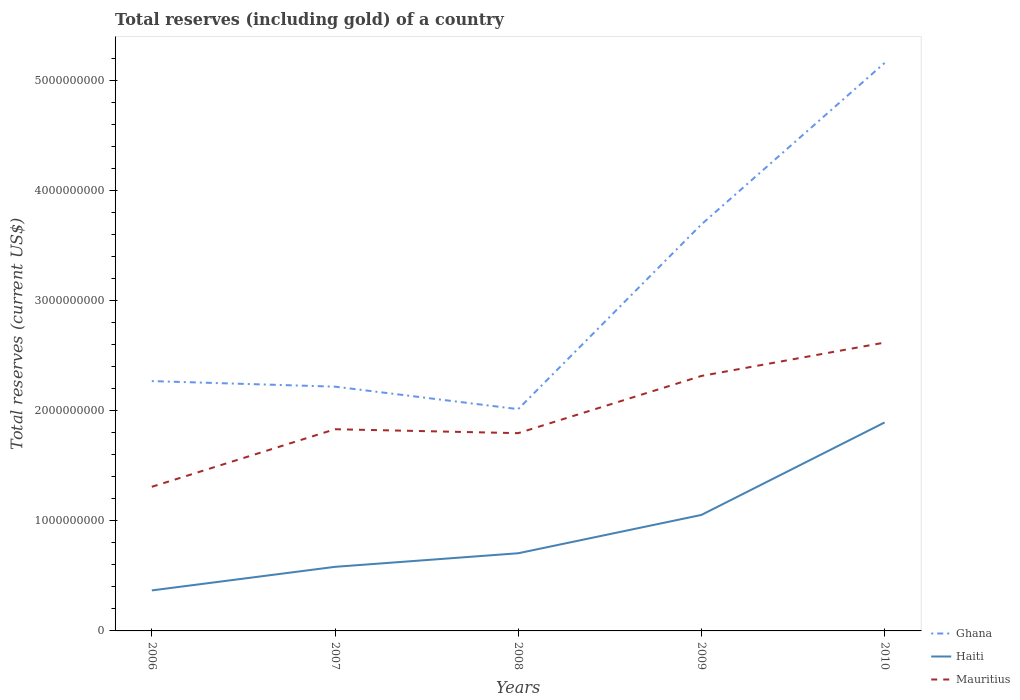Is the number of lines equal to the number of legend labels?
Your answer should be compact. Yes. Across all years, what is the maximum total reserves (including gold) in Haiti?
Your answer should be compact. 3.68e+08. What is the total total reserves (including gold) in Ghana in the graph?
Offer a terse response. 2.55e+08. What is the difference between the highest and the second highest total reserves (including gold) in Mauritius?
Offer a very short reply. 1.31e+09. Is the total reserves (including gold) in Ghana strictly greater than the total reserves (including gold) in Haiti over the years?
Ensure brevity in your answer.  No. What is the difference between two consecutive major ticks on the Y-axis?
Give a very brief answer. 1.00e+09. Does the graph contain any zero values?
Give a very brief answer. No. Does the graph contain grids?
Your answer should be very brief. No. Where does the legend appear in the graph?
Offer a terse response. Bottom right. How many legend labels are there?
Give a very brief answer. 3. What is the title of the graph?
Provide a short and direct response. Total reserves (including gold) of a country. Does "Guinea-Bissau" appear as one of the legend labels in the graph?
Ensure brevity in your answer.  No. What is the label or title of the Y-axis?
Give a very brief answer. Total reserves (current US$). What is the Total reserves (current US$) in Ghana in 2006?
Give a very brief answer. 2.27e+09. What is the Total reserves (current US$) of Haiti in 2006?
Your response must be concise. 3.68e+08. What is the Total reserves (current US$) in Mauritius in 2006?
Give a very brief answer. 1.31e+09. What is the Total reserves (current US$) of Ghana in 2007?
Keep it short and to the point. 2.22e+09. What is the Total reserves (current US$) in Haiti in 2007?
Give a very brief answer. 5.82e+08. What is the Total reserves (current US$) of Mauritius in 2007?
Keep it short and to the point. 1.83e+09. What is the Total reserves (current US$) of Ghana in 2008?
Your answer should be very brief. 2.01e+09. What is the Total reserves (current US$) in Haiti in 2008?
Make the answer very short. 7.05e+08. What is the Total reserves (current US$) in Mauritius in 2008?
Offer a very short reply. 1.80e+09. What is the Total reserves (current US$) of Ghana in 2009?
Provide a succinct answer. 3.69e+09. What is the Total reserves (current US$) in Haiti in 2009?
Keep it short and to the point. 1.05e+09. What is the Total reserves (current US$) of Mauritius in 2009?
Your response must be concise. 2.32e+09. What is the Total reserves (current US$) of Ghana in 2010?
Your answer should be compact. 5.16e+09. What is the Total reserves (current US$) in Haiti in 2010?
Your response must be concise. 1.89e+09. What is the Total reserves (current US$) in Mauritius in 2010?
Make the answer very short. 2.62e+09. Across all years, what is the maximum Total reserves (current US$) in Ghana?
Offer a very short reply. 5.16e+09. Across all years, what is the maximum Total reserves (current US$) in Haiti?
Keep it short and to the point. 1.89e+09. Across all years, what is the maximum Total reserves (current US$) of Mauritius?
Ensure brevity in your answer.  2.62e+09. Across all years, what is the minimum Total reserves (current US$) in Ghana?
Keep it short and to the point. 2.01e+09. Across all years, what is the minimum Total reserves (current US$) in Haiti?
Make the answer very short. 3.68e+08. Across all years, what is the minimum Total reserves (current US$) in Mauritius?
Provide a succinct answer. 1.31e+09. What is the total Total reserves (current US$) of Ghana in the graph?
Ensure brevity in your answer.  1.54e+1. What is the total Total reserves (current US$) in Haiti in the graph?
Provide a short and direct response. 4.60e+09. What is the total Total reserves (current US$) in Mauritius in the graph?
Provide a short and direct response. 9.87e+09. What is the difference between the Total reserves (current US$) of Ghana in 2006 and that in 2007?
Your answer should be very brief. 5.06e+07. What is the difference between the Total reserves (current US$) of Haiti in 2006 and that in 2007?
Your answer should be very brief. -2.14e+08. What is the difference between the Total reserves (current US$) in Mauritius in 2006 and that in 2007?
Your response must be concise. -5.23e+08. What is the difference between the Total reserves (current US$) in Ghana in 2006 and that in 2008?
Make the answer very short. 2.55e+08. What is the difference between the Total reserves (current US$) in Haiti in 2006 and that in 2008?
Keep it short and to the point. -3.38e+08. What is the difference between the Total reserves (current US$) of Mauritius in 2006 and that in 2008?
Keep it short and to the point. -4.87e+08. What is the difference between the Total reserves (current US$) of Ghana in 2006 and that in 2009?
Make the answer very short. -1.42e+09. What is the difference between the Total reserves (current US$) in Haiti in 2006 and that in 2009?
Provide a succinct answer. -6.86e+08. What is the difference between the Total reserves (current US$) in Mauritius in 2006 and that in 2009?
Your answer should be compact. -1.01e+09. What is the difference between the Total reserves (current US$) in Ghana in 2006 and that in 2010?
Make the answer very short. -2.89e+09. What is the difference between the Total reserves (current US$) of Haiti in 2006 and that in 2010?
Your answer should be compact. -1.53e+09. What is the difference between the Total reserves (current US$) of Mauritius in 2006 and that in 2010?
Your answer should be very brief. -1.31e+09. What is the difference between the Total reserves (current US$) in Ghana in 2007 and that in 2008?
Keep it short and to the point. 2.04e+08. What is the difference between the Total reserves (current US$) in Haiti in 2007 and that in 2008?
Offer a terse response. -1.23e+08. What is the difference between the Total reserves (current US$) of Mauritius in 2007 and that in 2008?
Provide a short and direct response. 3.56e+07. What is the difference between the Total reserves (current US$) in Ghana in 2007 and that in 2009?
Offer a terse response. -1.47e+09. What is the difference between the Total reserves (current US$) in Haiti in 2007 and that in 2009?
Ensure brevity in your answer.  -4.71e+08. What is the difference between the Total reserves (current US$) in Mauritius in 2007 and that in 2009?
Offer a terse response. -4.84e+08. What is the difference between the Total reserves (current US$) of Ghana in 2007 and that in 2010?
Make the answer very short. -2.94e+09. What is the difference between the Total reserves (current US$) in Haiti in 2007 and that in 2010?
Your answer should be very brief. -1.31e+09. What is the difference between the Total reserves (current US$) in Mauritius in 2007 and that in 2010?
Ensure brevity in your answer.  -7.87e+08. What is the difference between the Total reserves (current US$) of Ghana in 2008 and that in 2009?
Your answer should be very brief. -1.68e+09. What is the difference between the Total reserves (current US$) in Haiti in 2008 and that in 2009?
Offer a terse response. -3.48e+08. What is the difference between the Total reserves (current US$) of Mauritius in 2008 and that in 2009?
Offer a terse response. -5.19e+08. What is the difference between the Total reserves (current US$) in Ghana in 2008 and that in 2010?
Give a very brief answer. -3.14e+09. What is the difference between the Total reserves (current US$) in Haiti in 2008 and that in 2010?
Your answer should be compact. -1.19e+09. What is the difference between the Total reserves (current US$) of Mauritius in 2008 and that in 2010?
Provide a short and direct response. -8.22e+08. What is the difference between the Total reserves (current US$) of Ghana in 2009 and that in 2010?
Offer a terse response. -1.47e+09. What is the difference between the Total reserves (current US$) of Haiti in 2009 and that in 2010?
Your answer should be very brief. -8.40e+08. What is the difference between the Total reserves (current US$) of Mauritius in 2009 and that in 2010?
Your answer should be very brief. -3.03e+08. What is the difference between the Total reserves (current US$) of Ghana in 2006 and the Total reserves (current US$) of Haiti in 2007?
Keep it short and to the point. 1.69e+09. What is the difference between the Total reserves (current US$) in Ghana in 2006 and the Total reserves (current US$) in Mauritius in 2007?
Give a very brief answer. 4.37e+08. What is the difference between the Total reserves (current US$) in Haiti in 2006 and the Total reserves (current US$) in Mauritius in 2007?
Make the answer very short. -1.46e+09. What is the difference between the Total reserves (current US$) of Ghana in 2006 and the Total reserves (current US$) of Haiti in 2008?
Make the answer very short. 1.56e+09. What is the difference between the Total reserves (current US$) in Ghana in 2006 and the Total reserves (current US$) in Mauritius in 2008?
Ensure brevity in your answer.  4.73e+08. What is the difference between the Total reserves (current US$) of Haiti in 2006 and the Total reserves (current US$) of Mauritius in 2008?
Your answer should be very brief. -1.43e+09. What is the difference between the Total reserves (current US$) of Ghana in 2006 and the Total reserves (current US$) of Haiti in 2009?
Ensure brevity in your answer.  1.22e+09. What is the difference between the Total reserves (current US$) in Ghana in 2006 and the Total reserves (current US$) in Mauritius in 2009?
Ensure brevity in your answer.  -4.66e+07. What is the difference between the Total reserves (current US$) of Haiti in 2006 and the Total reserves (current US$) of Mauritius in 2009?
Ensure brevity in your answer.  -1.95e+09. What is the difference between the Total reserves (current US$) in Ghana in 2006 and the Total reserves (current US$) in Haiti in 2010?
Your answer should be compact. 3.76e+08. What is the difference between the Total reserves (current US$) of Ghana in 2006 and the Total reserves (current US$) of Mauritius in 2010?
Your answer should be very brief. -3.50e+08. What is the difference between the Total reserves (current US$) in Haiti in 2006 and the Total reserves (current US$) in Mauritius in 2010?
Your answer should be compact. -2.25e+09. What is the difference between the Total reserves (current US$) in Ghana in 2007 and the Total reserves (current US$) in Haiti in 2008?
Keep it short and to the point. 1.51e+09. What is the difference between the Total reserves (current US$) in Ghana in 2007 and the Total reserves (current US$) in Mauritius in 2008?
Give a very brief answer. 4.22e+08. What is the difference between the Total reserves (current US$) in Haiti in 2007 and the Total reserves (current US$) in Mauritius in 2008?
Offer a very short reply. -1.21e+09. What is the difference between the Total reserves (current US$) of Ghana in 2007 and the Total reserves (current US$) of Haiti in 2009?
Your response must be concise. 1.16e+09. What is the difference between the Total reserves (current US$) in Ghana in 2007 and the Total reserves (current US$) in Mauritius in 2009?
Give a very brief answer. -9.72e+07. What is the difference between the Total reserves (current US$) in Haiti in 2007 and the Total reserves (current US$) in Mauritius in 2009?
Provide a succinct answer. -1.73e+09. What is the difference between the Total reserves (current US$) of Ghana in 2007 and the Total reserves (current US$) of Haiti in 2010?
Provide a short and direct response. 3.25e+08. What is the difference between the Total reserves (current US$) in Ghana in 2007 and the Total reserves (current US$) in Mauritius in 2010?
Provide a short and direct response. -4.00e+08. What is the difference between the Total reserves (current US$) of Haiti in 2007 and the Total reserves (current US$) of Mauritius in 2010?
Offer a very short reply. -2.04e+09. What is the difference between the Total reserves (current US$) of Ghana in 2008 and the Total reserves (current US$) of Haiti in 2009?
Make the answer very short. 9.61e+08. What is the difference between the Total reserves (current US$) of Ghana in 2008 and the Total reserves (current US$) of Mauritius in 2009?
Provide a short and direct response. -3.01e+08. What is the difference between the Total reserves (current US$) of Haiti in 2008 and the Total reserves (current US$) of Mauritius in 2009?
Offer a terse response. -1.61e+09. What is the difference between the Total reserves (current US$) of Ghana in 2008 and the Total reserves (current US$) of Haiti in 2010?
Offer a terse response. 1.21e+08. What is the difference between the Total reserves (current US$) of Ghana in 2008 and the Total reserves (current US$) of Mauritius in 2010?
Offer a terse response. -6.04e+08. What is the difference between the Total reserves (current US$) of Haiti in 2008 and the Total reserves (current US$) of Mauritius in 2010?
Ensure brevity in your answer.  -1.91e+09. What is the difference between the Total reserves (current US$) of Ghana in 2009 and the Total reserves (current US$) of Haiti in 2010?
Offer a very short reply. 1.80e+09. What is the difference between the Total reserves (current US$) of Ghana in 2009 and the Total reserves (current US$) of Mauritius in 2010?
Give a very brief answer. 1.07e+09. What is the difference between the Total reserves (current US$) of Haiti in 2009 and the Total reserves (current US$) of Mauritius in 2010?
Provide a short and direct response. -1.57e+09. What is the average Total reserves (current US$) of Ghana per year?
Provide a short and direct response. 3.07e+09. What is the average Total reserves (current US$) of Haiti per year?
Provide a succinct answer. 9.20e+08. What is the average Total reserves (current US$) of Mauritius per year?
Keep it short and to the point. 1.97e+09. In the year 2006, what is the difference between the Total reserves (current US$) in Ghana and Total reserves (current US$) in Haiti?
Offer a very short reply. 1.90e+09. In the year 2006, what is the difference between the Total reserves (current US$) of Ghana and Total reserves (current US$) of Mauritius?
Ensure brevity in your answer.  9.60e+08. In the year 2006, what is the difference between the Total reserves (current US$) of Haiti and Total reserves (current US$) of Mauritius?
Offer a terse response. -9.41e+08. In the year 2007, what is the difference between the Total reserves (current US$) of Ghana and Total reserves (current US$) of Haiti?
Your response must be concise. 1.64e+09. In the year 2007, what is the difference between the Total reserves (current US$) of Ghana and Total reserves (current US$) of Mauritius?
Give a very brief answer. 3.87e+08. In the year 2007, what is the difference between the Total reserves (current US$) of Haiti and Total reserves (current US$) of Mauritius?
Offer a terse response. -1.25e+09. In the year 2008, what is the difference between the Total reserves (current US$) of Ghana and Total reserves (current US$) of Haiti?
Give a very brief answer. 1.31e+09. In the year 2008, what is the difference between the Total reserves (current US$) of Ghana and Total reserves (current US$) of Mauritius?
Ensure brevity in your answer.  2.18e+08. In the year 2008, what is the difference between the Total reserves (current US$) in Haiti and Total reserves (current US$) in Mauritius?
Your answer should be very brief. -1.09e+09. In the year 2009, what is the difference between the Total reserves (current US$) of Ghana and Total reserves (current US$) of Haiti?
Your answer should be very brief. 2.64e+09. In the year 2009, what is the difference between the Total reserves (current US$) of Ghana and Total reserves (current US$) of Mauritius?
Offer a terse response. 1.38e+09. In the year 2009, what is the difference between the Total reserves (current US$) in Haiti and Total reserves (current US$) in Mauritius?
Keep it short and to the point. -1.26e+09. In the year 2010, what is the difference between the Total reserves (current US$) of Ghana and Total reserves (current US$) of Haiti?
Ensure brevity in your answer.  3.27e+09. In the year 2010, what is the difference between the Total reserves (current US$) in Ghana and Total reserves (current US$) in Mauritius?
Your response must be concise. 2.54e+09. In the year 2010, what is the difference between the Total reserves (current US$) in Haiti and Total reserves (current US$) in Mauritius?
Provide a short and direct response. -7.26e+08. What is the ratio of the Total reserves (current US$) of Ghana in 2006 to that in 2007?
Provide a short and direct response. 1.02. What is the ratio of the Total reserves (current US$) of Haiti in 2006 to that in 2007?
Your answer should be very brief. 0.63. What is the ratio of the Total reserves (current US$) of Mauritius in 2006 to that in 2007?
Provide a succinct answer. 0.71. What is the ratio of the Total reserves (current US$) in Ghana in 2006 to that in 2008?
Your answer should be very brief. 1.13. What is the ratio of the Total reserves (current US$) of Haiti in 2006 to that in 2008?
Provide a succinct answer. 0.52. What is the ratio of the Total reserves (current US$) in Mauritius in 2006 to that in 2008?
Provide a short and direct response. 0.73. What is the ratio of the Total reserves (current US$) in Ghana in 2006 to that in 2009?
Offer a very short reply. 0.61. What is the ratio of the Total reserves (current US$) in Haiti in 2006 to that in 2009?
Your answer should be very brief. 0.35. What is the ratio of the Total reserves (current US$) in Mauritius in 2006 to that in 2009?
Keep it short and to the point. 0.57. What is the ratio of the Total reserves (current US$) of Ghana in 2006 to that in 2010?
Make the answer very short. 0.44. What is the ratio of the Total reserves (current US$) in Haiti in 2006 to that in 2010?
Offer a terse response. 0.19. What is the ratio of the Total reserves (current US$) of Mauritius in 2006 to that in 2010?
Keep it short and to the point. 0.5. What is the ratio of the Total reserves (current US$) in Ghana in 2007 to that in 2008?
Offer a very short reply. 1.1. What is the ratio of the Total reserves (current US$) of Haiti in 2007 to that in 2008?
Make the answer very short. 0.83. What is the ratio of the Total reserves (current US$) of Mauritius in 2007 to that in 2008?
Keep it short and to the point. 1.02. What is the ratio of the Total reserves (current US$) of Ghana in 2007 to that in 2009?
Provide a short and direct response. 0.6. What is the ratio of the Total reserves (current US$) of Haiti in 2007 to that in 2009?
Provide a short and direct response. 0.55. What is the ratio of the Total reserves (current US$) in Mauritius in 2007 to that in 2009?
Your answer should be very brief. 0.79. What is the ratio of the Total reserves (current US$) in Ghana in 2007 to that in 2010?
Offer a very short reply. 0.43. What is the ratio of the Total reserves (current US$) in Haiti in 2007 to that in 2010?
Make the answer very short. 0.31. What is the ratio of the Total reserves (current US$) of Mauritius in 2007 to that in 2010?
Provide a short and direct response. 0.7. What is the ratio of the Total reserves (current US$) of Ghana in 2008 to that in 2009?
Give a very brief answer. 0.55. What is the ratio of the Total reserves (current US$) in Haiti in 2008 to that in 2009?
Your answer should be compact. 0.67. What is the ratio of the Total reserves (current US$) of Mauritius in 2008 to that in 2009?
Give a very brief answer. 0.78. What is the ratio of the Total reserves (current US$) of Ghana in 2008 to that in 2010?
Offer a very short reply. 0.39. What is the ratio of the Total reserves (current US$) of Haiti in 2008 to that in 2010?
Your answer should be compact. 0.37. What is the ratio of the Total reserves (current US$) in Mauritius in 2008 to that in 2010?
Your answer should be very brief. 0.69. What is the ratio of the Total reserves (current US$) in Ghana in 2009 to that in 2010?
Your answer should be compact. 0.72. What is the ratio of the Total reserves (current US$) in Haiti in 2009 to that in 2010?
Your answer should be very brief. 0.56. What is the ratio of the Total reserves (current US$) of Mauritius in 2009 to that in 2010?
Your answer should be compact. 0.88. What is the difference between the highest and the second highest Total reserves (current US$) in Ghana?
Ensure brevity in your answer.  1.47e+09. What is the difference between the highest and the second highest Total reserves (current US$) in Haiti?
Offer a terse response. 8.40e+08. What is the difference between the highest and the second highest Total reserves (current US$) of Mauritius?
Make the answer very short. 3.03e+08. What is the difference between the highest and the lowest Total reserves (current US$) of Ghana?
Give a very brief answer. 3.14e+09. What is the difference between the highest and the lowest Total reserves (current US$) of Haiti?
Make the answer very short. 1.53e+09. What is the difference between the highest and the lowest Total reserves (current US$) of Mauritius?
Make the answer very short. 1.31e+09. 